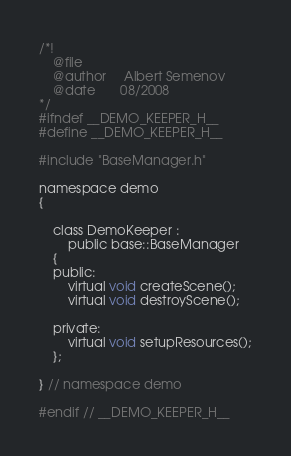<code> <loc_0><loc_0><loc_500><loc_500><_C_>/*!
	@file
	@author		Albert Semenov
	@date		08/2008
*/
#ifndef __DEMO_KEEPER_H__
#define __DEMO_KEEPER_H__

#include "BaseManager.h"

namespace demo
{

	class DemoKeeper :
		public base::BaseManager
	{
	public:
		virtual void createScene();
		virtual void destroyScene();

	private:
		virtual void setupResources();
	};

} // namespace demo

#endif // __DEMO_KEEPER_H__
</code> 